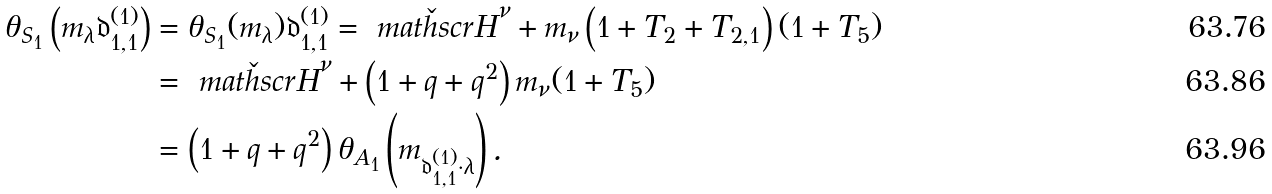<formula> <loc_0><loc_0><loc_500><loc_500>\theta _ { S _ { 1 } } \left ( m _ { \lambda } \mathfrak { d } ^ { ( 1 ) } _ { 1 , 1 } \right ) & = \theta _ { S _ { 1 } } ( m _ { \lambda } ) \mathfrak { d } ^ { ( 1 ) } _ { 1 , 1 } = \check { \ m a t h s c r { H } } ^ { \nu } + m _ { \nu } \left ( 1 + T _ { 2 } + T _ { 2 , 1 } \right ) ( 1 + T _ { 5 } ) \\ & = \check { \ m a t h s c r { H } } ^ { \nu } + \left ( 1 + q + q ^ { 2 } \right ) m _ { \nu } ( 1 + T _ { 5 } ) \\ & = \left ( 1 + q + q ^ { 2 } \right ) \theta _ { A _ { 1 } } \left ( m _ { \mathfrak { d } ^ { ( 1 ) } _ { 1 , 1 } \cdot \lambda } \right ) .</formula> 